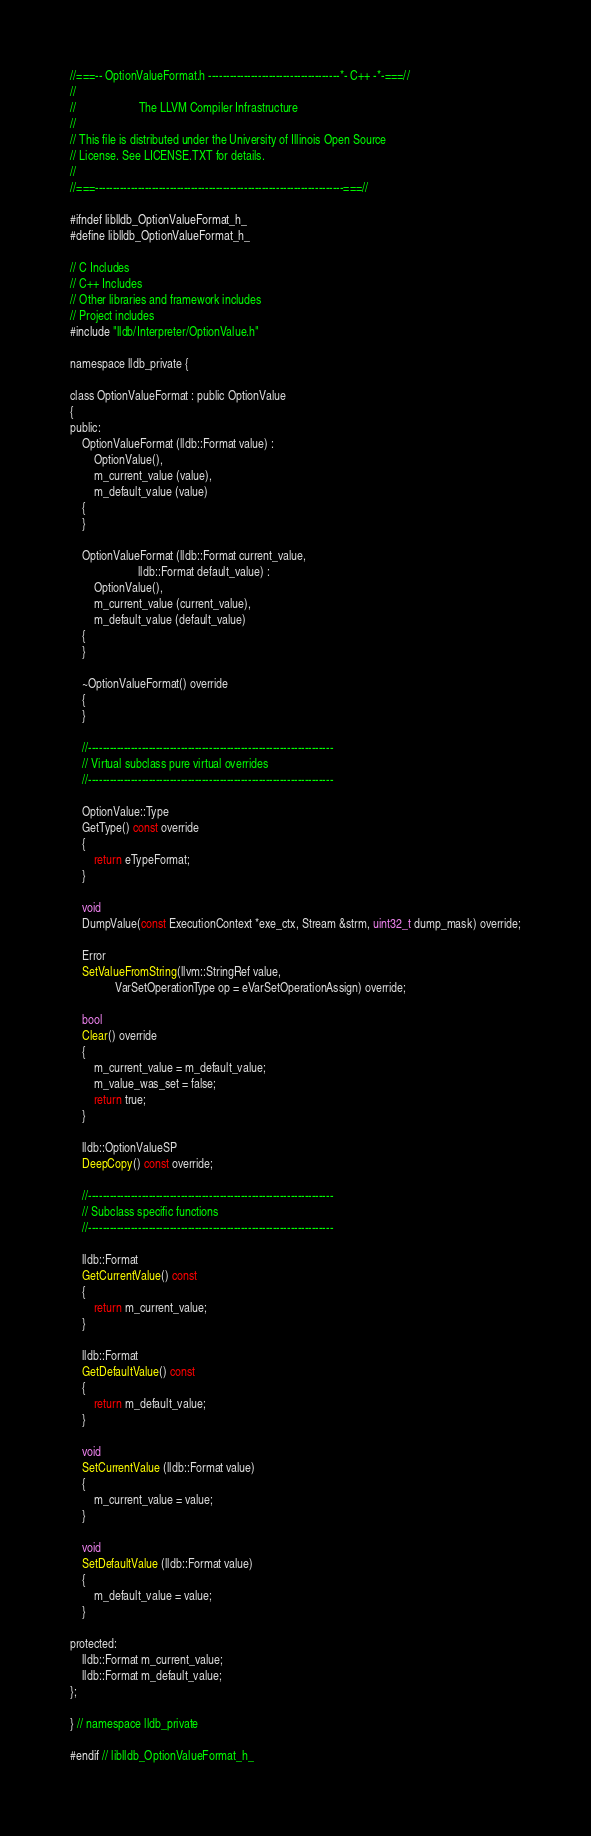<code> <loc_0><loc_0><loc_500><loc_500><_C_>//===-- OptionValueFormat.h -------------------------------------*- C++ -*-===//
//
//                     The LLVM Compiler Infrastructure
//
// This file is distributed under the University of Illinois Open Source
// License. See LICENSE.TXT for details.
//
//===----------------------------------------------------------------------===//

#ifndef liblldb_OptionValueFormat_h_
#define liblldb_OptionValueFormat_h_

// C Includes
// C++ Includes
// Other libraries and framework includes
// Project includes
#include "lldb/Interpreter/OptionValue.h"

namespace lldb_private {

class OptionValueFormat : public OptionValue
{
public:
    OptionValueFormat (lldb::Format value) :
        OptionValue(),
        m_current_value (value),
        m_default_value (value)
    {
    }

    OptionValueFormat (lldb::Format current_value,
                       lldb::Format default_value) :
        OptionValue(),
        m_current_value (current_value),
        m_default_value (default_value)
    {
    }
    
    ~OptionValueFormat() override
    {
    }
    
    //---------------------------------------------------------------------
    // Virtual subclass pure virtual overrides
    //---------------------------------------------------------------------
    
    OptionValue::Type
    GetType() const override
    {
        return eTypeFormat;
    }
    
    void
    DumpValue(const ExecutionContext *exe_ctx, Stream &strm, uint32_t dump_mask) override;
    
    Error
    SetValueFromString(llvm::StringRef value,
		       VarSetOperationType op = eVarSetOperationAssign) override;
    
    bool
    Clear() override
    {
        m_current_value = m_default_value;
        m_value_was_set = false;
        return true;
    }

    lldb::OptionValueSP
    DeepCopy() const override;
    
    //---------------------------------------------------------------------
    // Subclass specific functions
    //---------------------------------------------------------------------
    
    lldb::Format
    GetCurrentValue() const
    {
        return m_current_value;
    }
    
    lldb::Format 
    GetDefaultValue() const
    {
        return m_default_value;
    }
    
    void
    SetCurrentValue (lldb::Format value)
    {
        m_current_value = value;
    }
    
    void
    SetDefaultValue (lldb::Format value)
    {
        m_default_value = value;
    }
    
protected:
    lldb::Format m_current_value;
    lldb::Format m_default_value;
};

} // namespace lldb_private

#endif // liblldb_OptionValueFormat_h_
</code> 